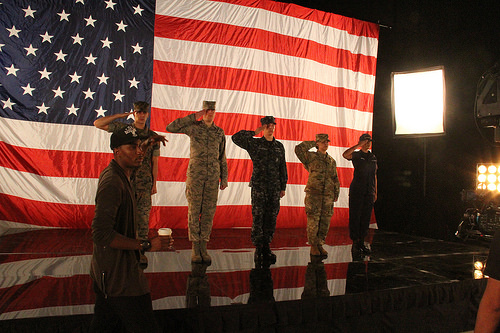<image>
Can you confirm if the light is behind the man? No. The light is not behind the man. From this viewpoint, the light appears to be positioned elsewhere in the scene. 